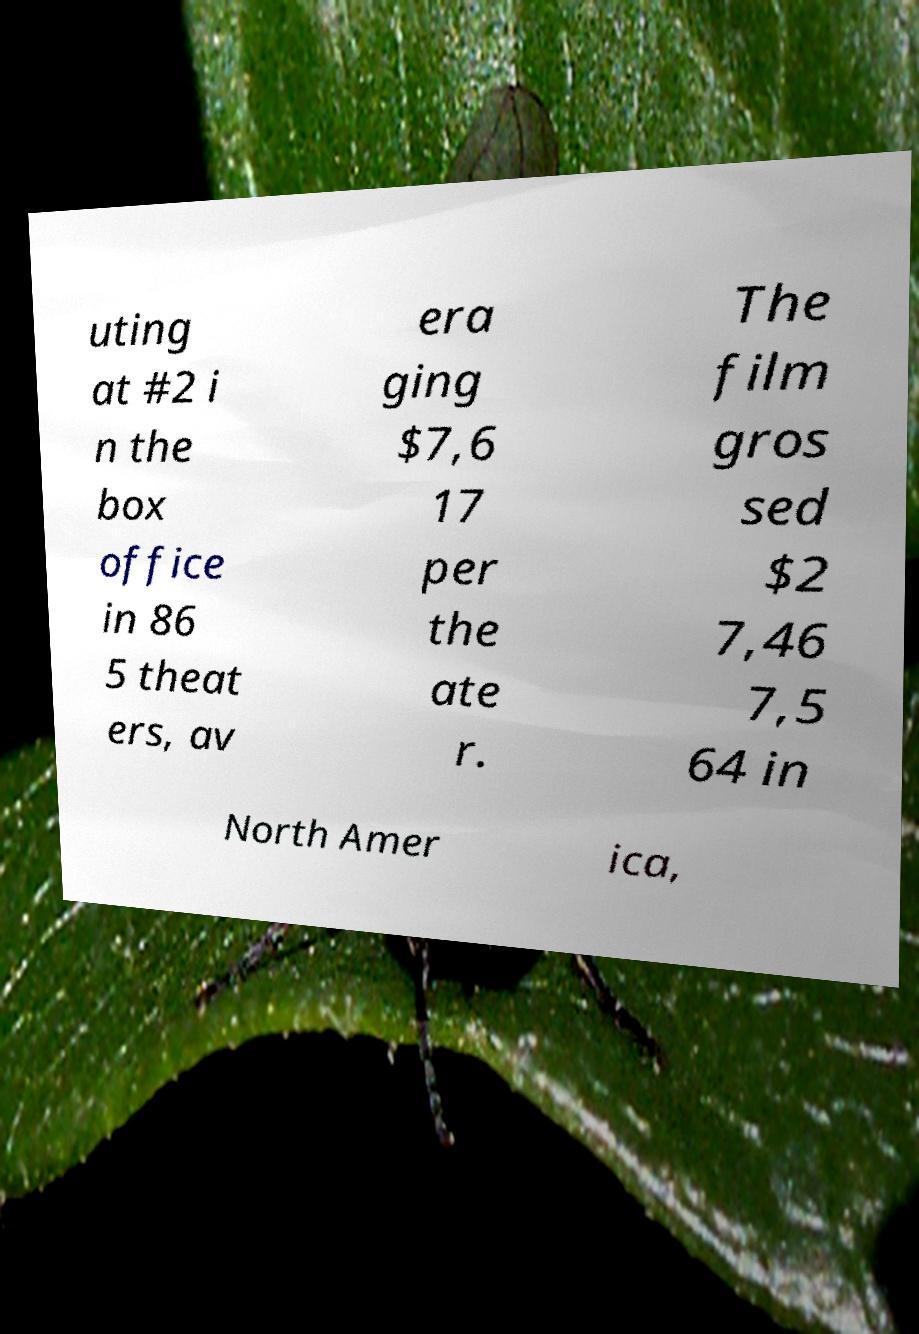Could you assist in decoding the text presented in this image and type it out clearly? uting at #2 i n the box office in 86 5 theat ers, av era ging $7,6 17 per the ate r. The film gros sed $2 7,46 7,5 64 in North Amer ica, 